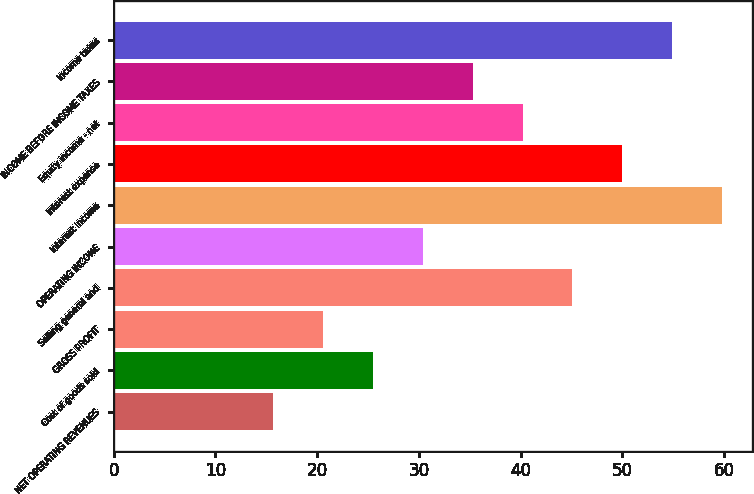<chart> <loc_0><loc_0><loc_500><loc_500><bar_chart><fcel>NET OPERATING REVENUES<fcel>Cost of goods sold<fcel>GROSS PROFIT<fcel>Selling general and<fcel>OPERATING INCOME<fcel>Interest income<fcel>Interest expense<fcel>Equity income - net<fcel>INCOME BEFORE INCOME TAXES<fcel>Income taxes<nl><fcel>15.7<fcel>25.5<fcel>20.6<fcel>45.1<fcel>30.4<fcel>59.8<fcel>50<fcel>40.2<fcel>35.3<fcel>54.9<nl></chart> 